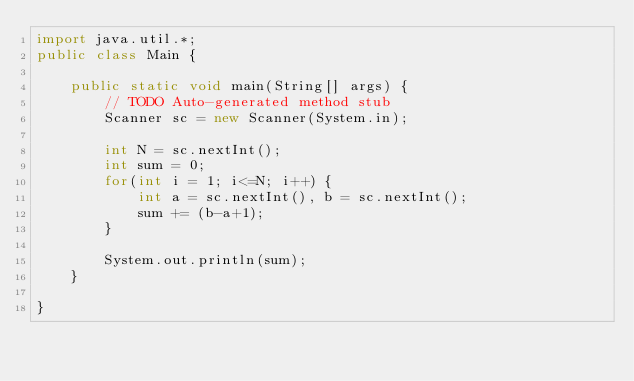Convert code to text. <code><loc_0><loc_0><loc_500><loc_500><_Java_>import java.util.*;
public class Main {

	public static void main(String[] args) {
		// TODO Auto-generated method stub
		Scanner sc = new Scanner(System.in);
		
		int N = sc.nextInt();
		int sum = 0;
		for(int i = 1; i<=N; i++) {
			int a = sc.nextInt(), b = sc.nextInt();
			sum += (b-a+1);
		}
		
		System.out.println(sum);
	}

}
</code> 